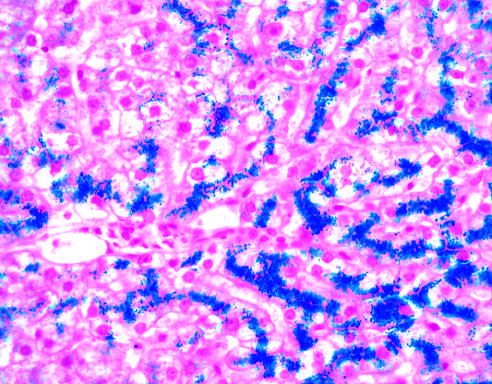s failure to stain normal at this stage of disease, even with such abundant iron?
Answer the question using a single word or phrase. No 